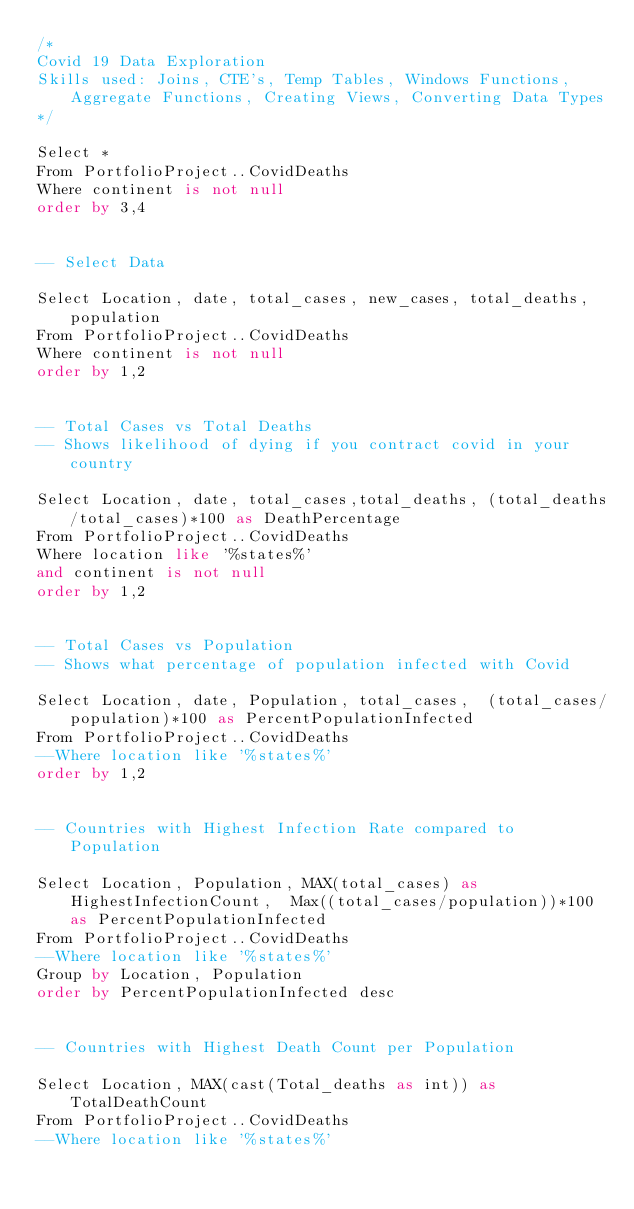Convert code to text. <code><loc_0><loc_0><loc_500><loc_500><_SQL_>/*
Covid 19 Data Exploration 
Skills used: Joins, CTE's, Temp Tables, Windows Functions, Aggregate Functions, Creating Views, Converting Data Types
*/

Select *
From PortfolioProject..CovidDeaths
Where continent is not null 
order by 3,4


-- Select Data 

Select Location, date, total_cases, new_cases, total_deaths, population
From PortfolioProject..CovidDeaths
Where continent is not null 
order by 1,2


-- Total Cases vs Total Deaths
-- Shows likelihood of dying if you contract covid in your country

Select Location, date, total_cases,total_deaths, (total_deaths/total_cases)*100 as DeathPercentage
From PortfolioProject..CovidDeaths
Where location like '%states%'
and continent is not null 
order by 1,2


-- Total Cases vs Population
-- Shows what percentage of population infected with Covid

Select Location, date, Population, total_cases,  (total_cases/population)*100 as PercentPopulationInfected
From PortfolioProject..CovidDeaths
--Where location like '%states%'
order by 1,2


-- Countries with Highest Infection Rate compared to Population

Select Location, Population, MAX(total_cases) as HighestInfectionCount,  Max((total_cases/population))*100 as PercentPopulationInfected
From PortfolioProject..CovidDeaths
--Where location like '%states%'
Group by Location, Population
order by PercentPopulationInfected desc


-- Countries with Highest Death Count per Population

Select Location, MAX(cast(Total_deaths as int)) as TotalDeathCount
From PortfolioProject..CovidDeaths
--Where location like '%states%'</code> 